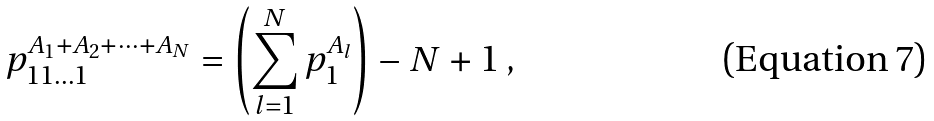Convert formula to latex. <formula><loc_0><loc_0><loc_500><loc_500>p _ { 1 1 \dots 1 } ^ { A _ { 1 } + A _ { 2 } + \dots + A _ { N } } = \left ( \sum _ { l = 1 } ^ { N } p _ { 1 } ^ { A _ { l } } \right ) - N + 1 \, ,</formula> 